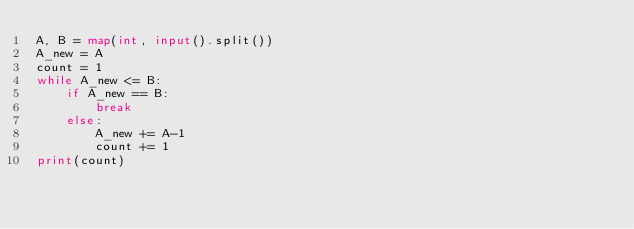Convert code to text. <code><loc_0><loc_0><loc_500><loc_500><_Python_>A, B = map(int, input().split())
A_new = A
count = 1
while A_new <= B:
    if A_new == B:
        break
    else:
        A_new += A-1
        count += 1
print(count)</code> 